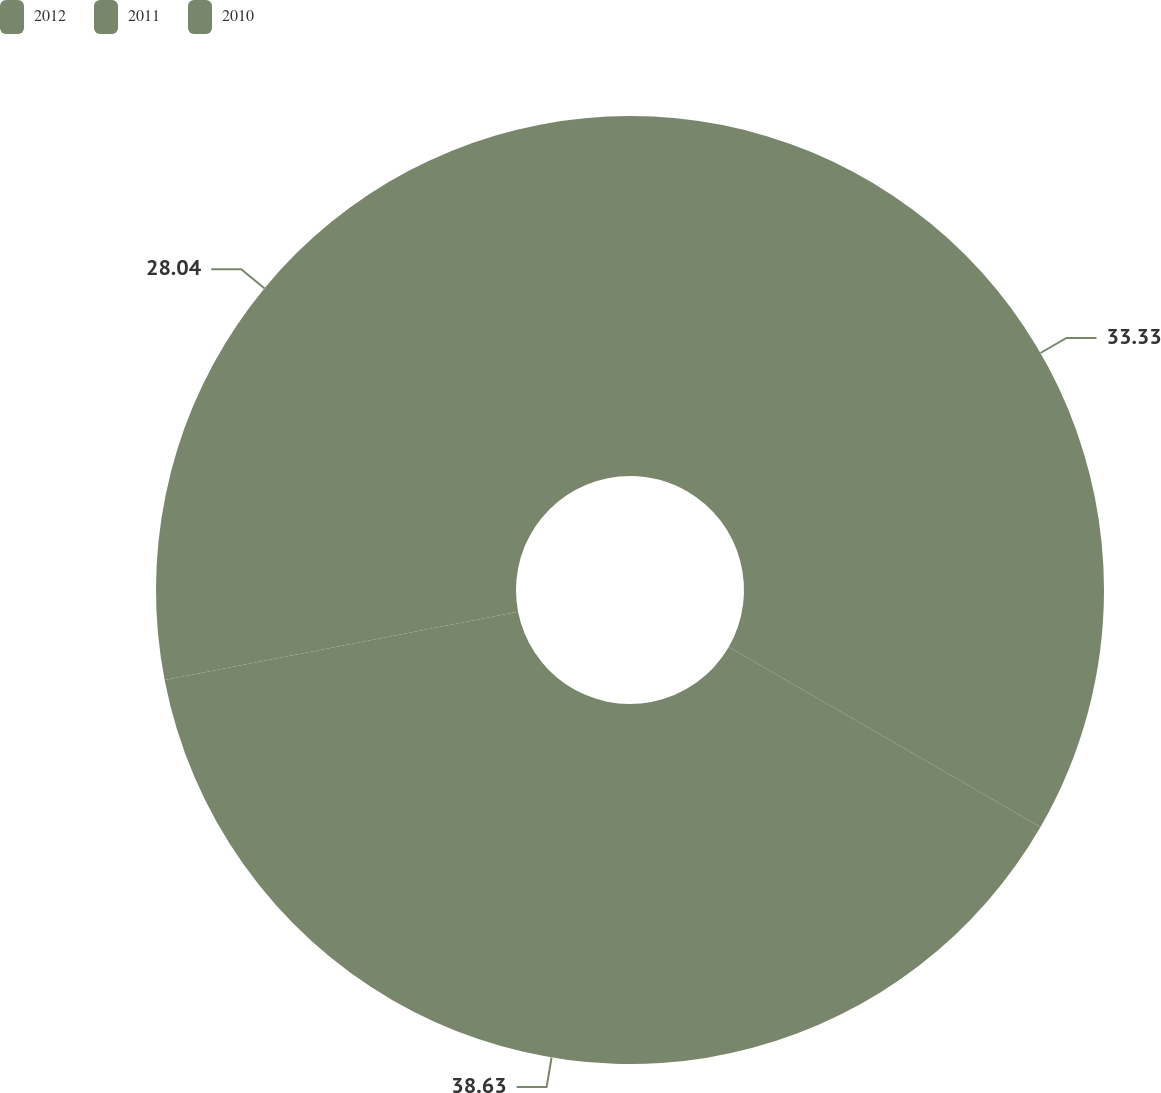Convert chart. <chart><loc_0><loc_0><loc_500><loc_500><pie_chart><fcel>2012<fcel>2011<fcel>2010<nl><fcel>33.33%<fcel>38.62%<fcel>28.04%<nl></chart> 